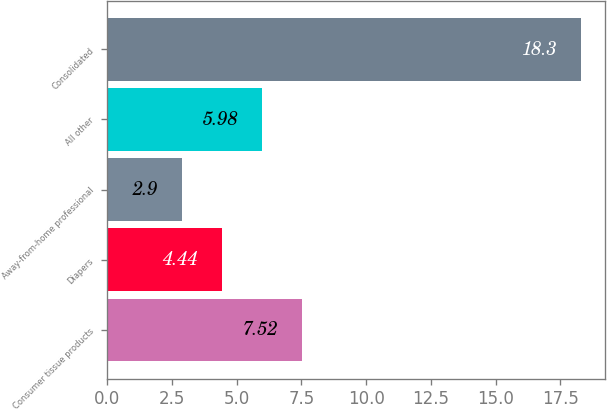Convert chart. <chart><loc_0><loc_0><loc_500><loc_500><bar_chart><fcel>Consumer tissue products<fcel>Diapers<fcel>Away-from-home professional<fcel>All other<fcel>Consolidated<nl><fcel>7.52<fcel>4.44<fcel>2.9<fcel>5.98<fcel>18.3<nl></chart> 